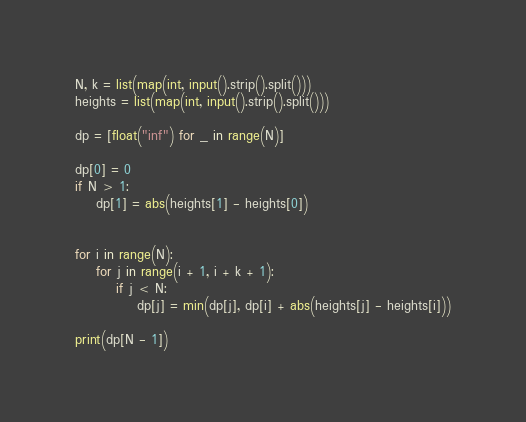<code> <loc_0><loc_0><loc_500><loc_500><_Python_>N, k = list(map(int, input().strip().split()))
heights = list(map(int, input().strip().split()))

dp = [float("inf") for _ in range(N)]

dp[0] = 0
if N > 1:
    dp[1] = abs(heights[1] - heights[0])


for i in range(N):
    for j in range(i + 1, i + k + 1):
        if j < N:
            dp[j] = min(dp[j], dp[i] + abs(heights[j] - heights[i]))

print(dp[N - 1])
</code> 